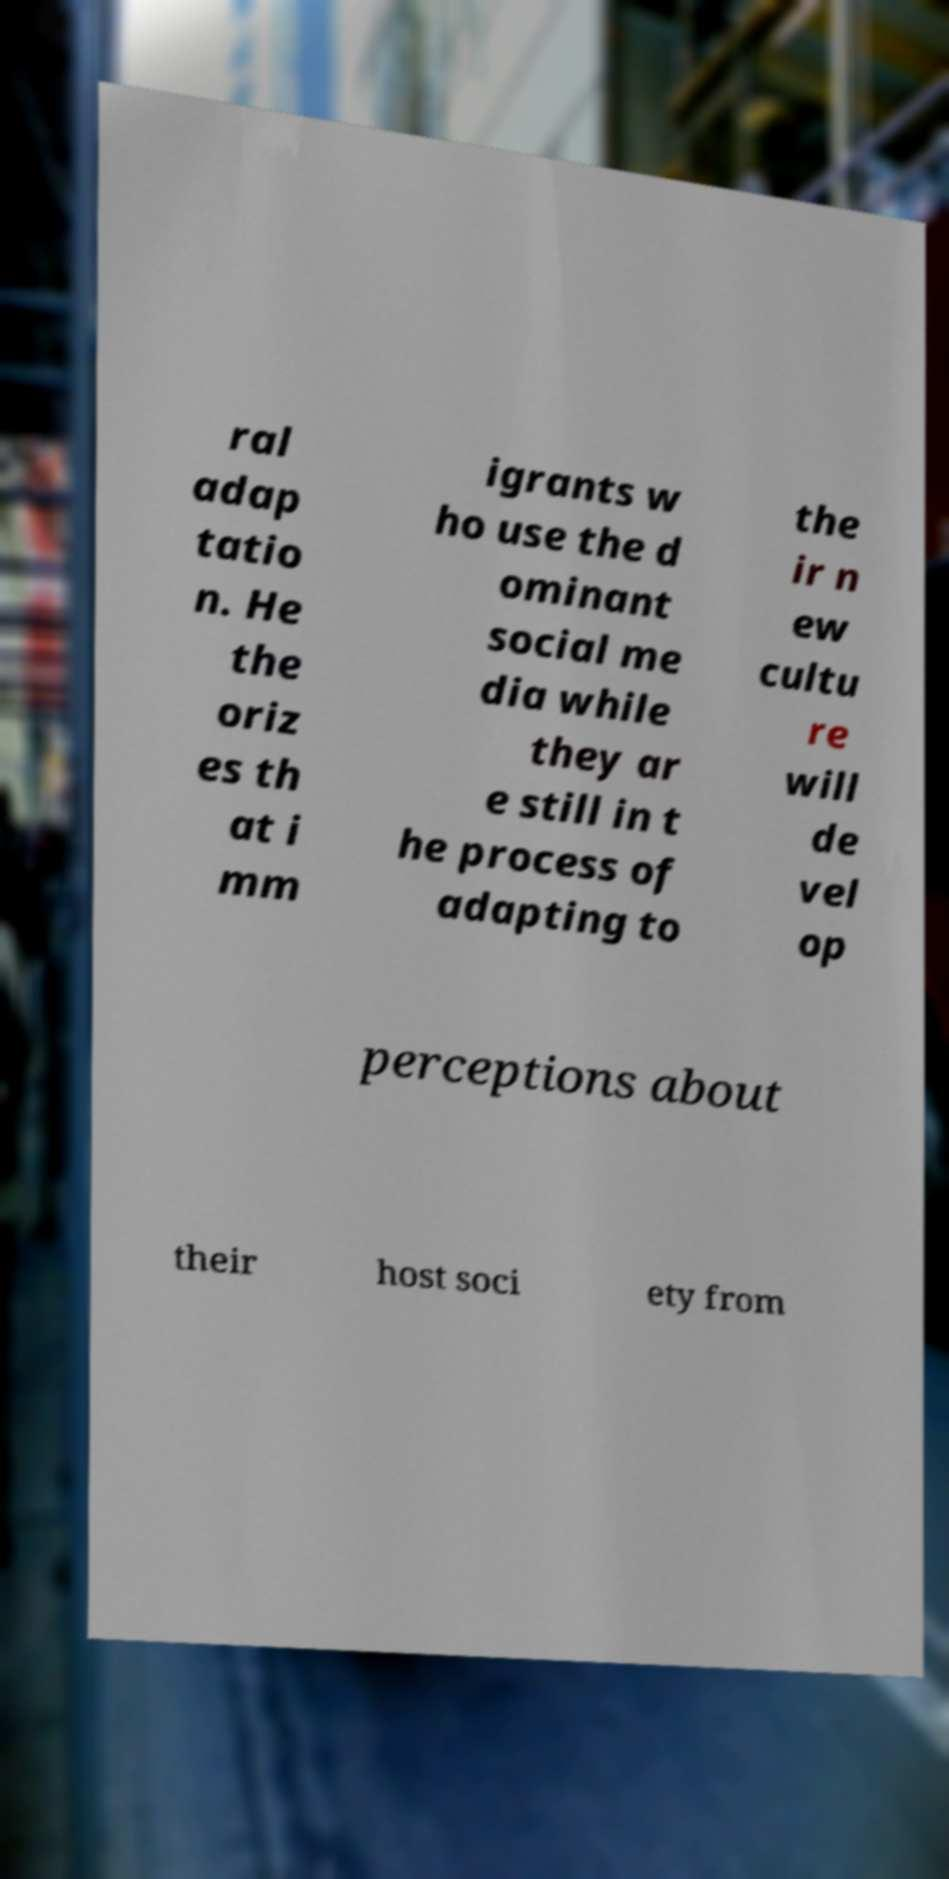Can you accurately transcribe the text from the provided image for me? ral adap tatio n. He the oriz es th at i mm igrants w ho use the d ominant social me dia while they ar e still in t he process of adapting to the ir n ew cultu re will de vel op perceptions about their host soci ety from 